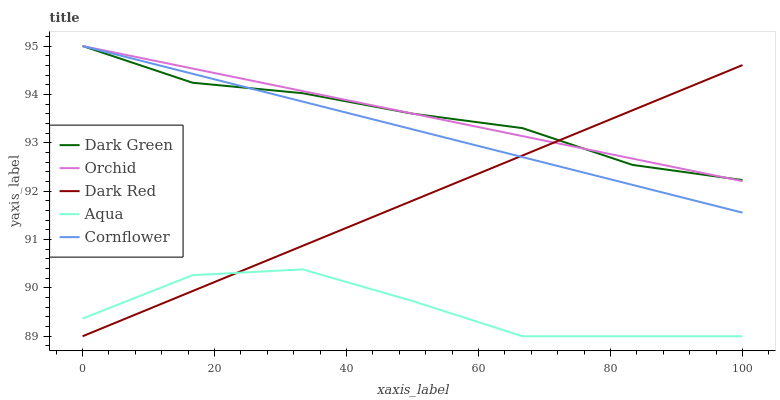Does Orchid have the minimum area under the curve?
Answer yes or no. No. Does Aqua have the maximum area under the curve?
Answer yes or no. No. Is Aqua the smoothest?
Answer yes or no. No. Is Orchid the roughest?
Answer yes or no. No. Does Orchid have the lowest value?
Answer yes or no. No. Does Aqua have the highest value?
Answer yes or no. No. Is Aqua less than Cornflower?
Answer yes or no. Yes. Is Dark Green greater than Aqua?
Answer yes or no. Yes. Does Aqua intersect Cornflower?
Answer yes or no. No. 